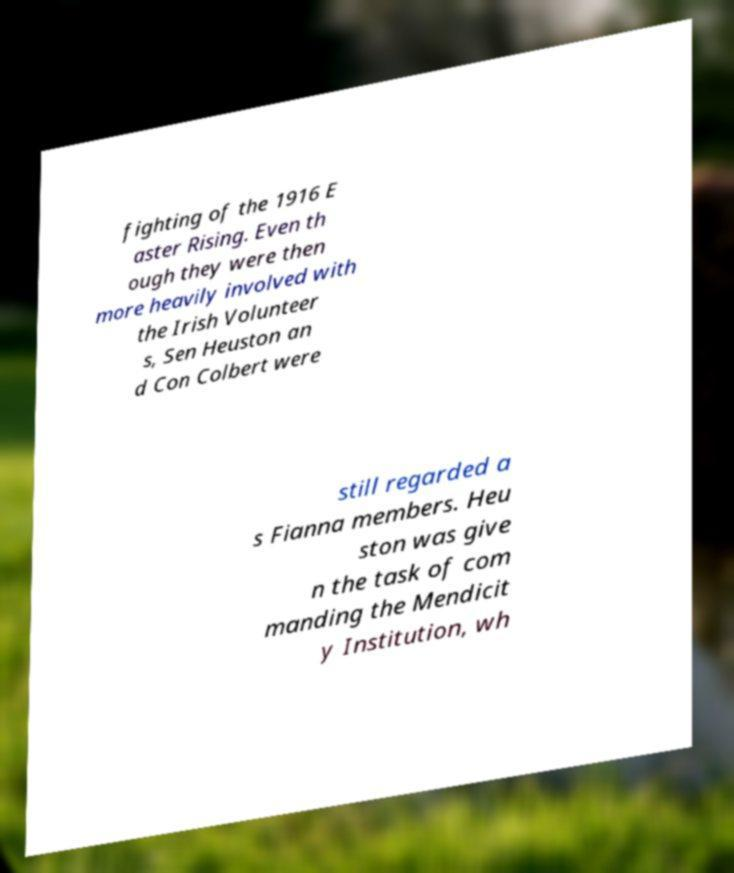What messages or text are displayed in this image? I need them in a readable, typed format. fighting of the 1916 E aster Rising. Even th ough they were then more heavily involved with the Irish Volunteer s, Sen Heuston an d Con Colbert were still regarded a s Fianna members. Heu ston was give n the task of com manding the Mendicit y Institution, wh 